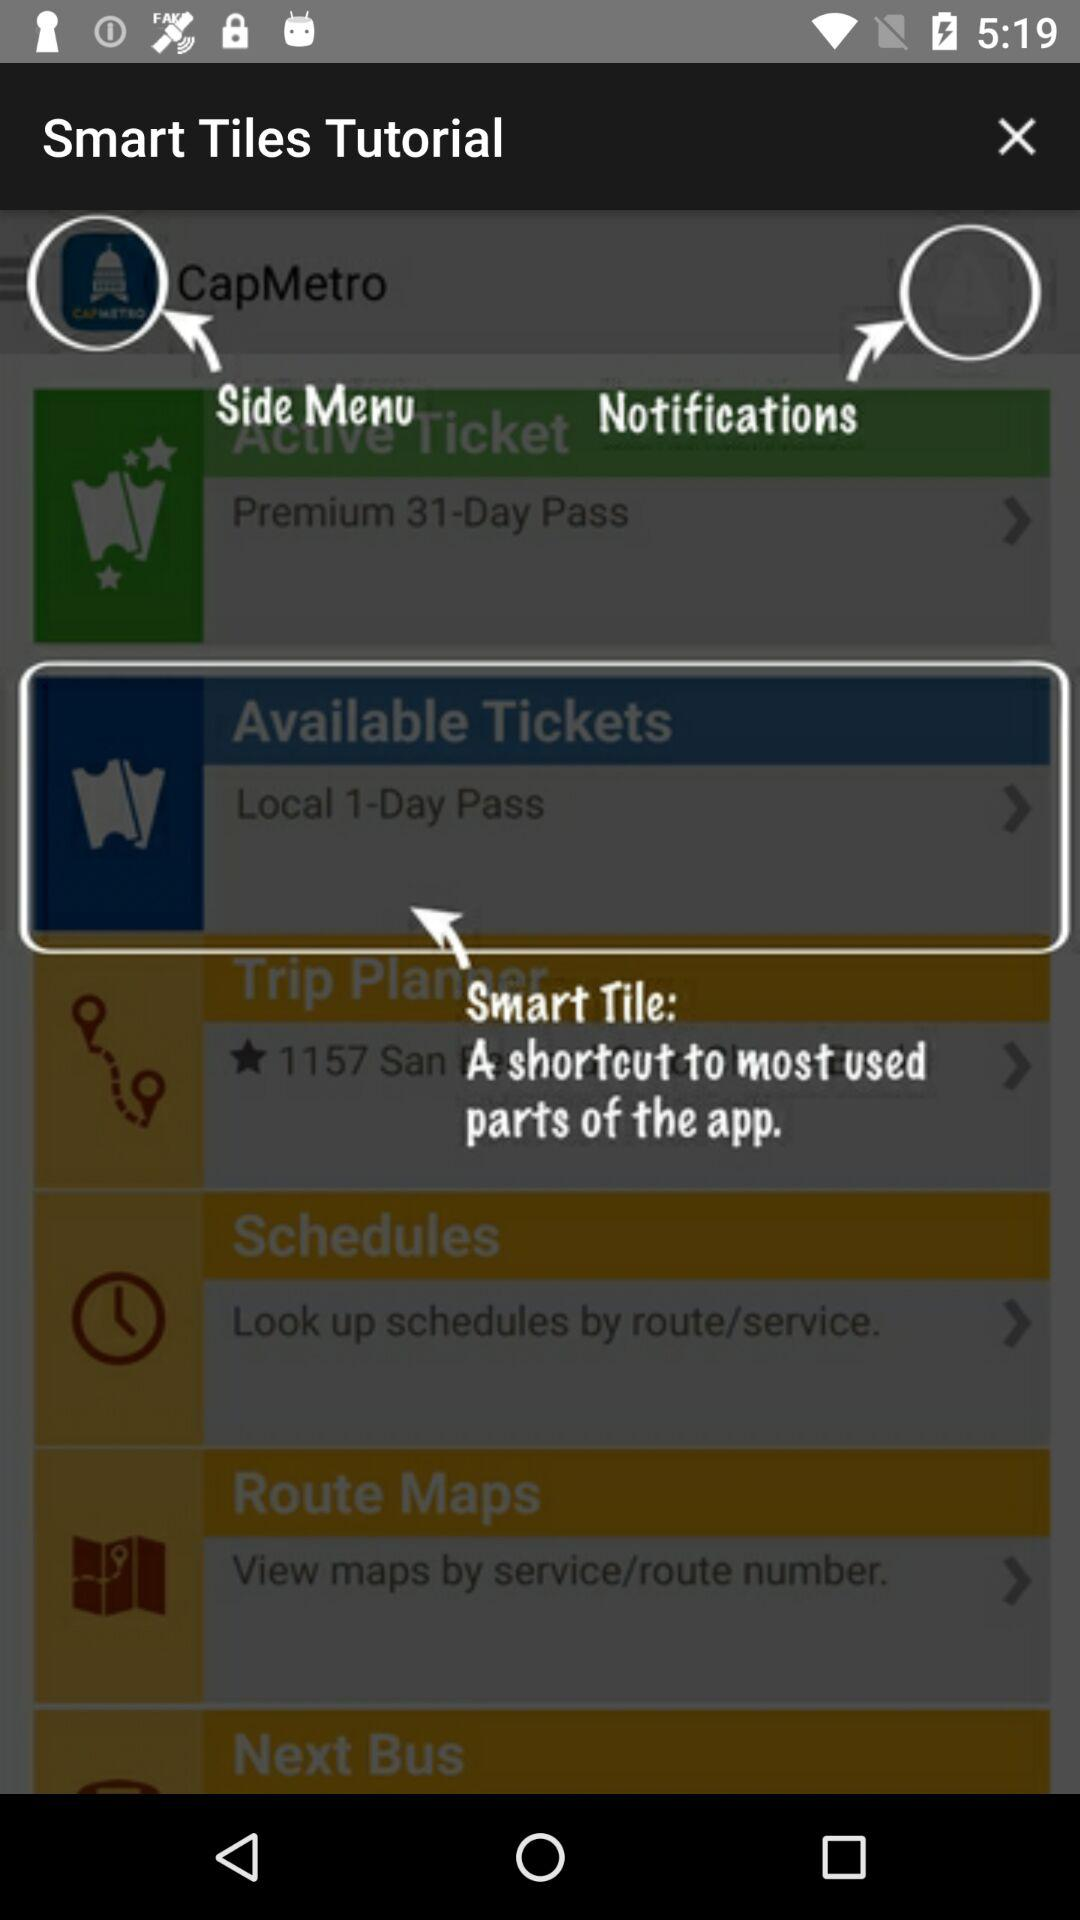What is the application name? The application name is "CapMetro". 